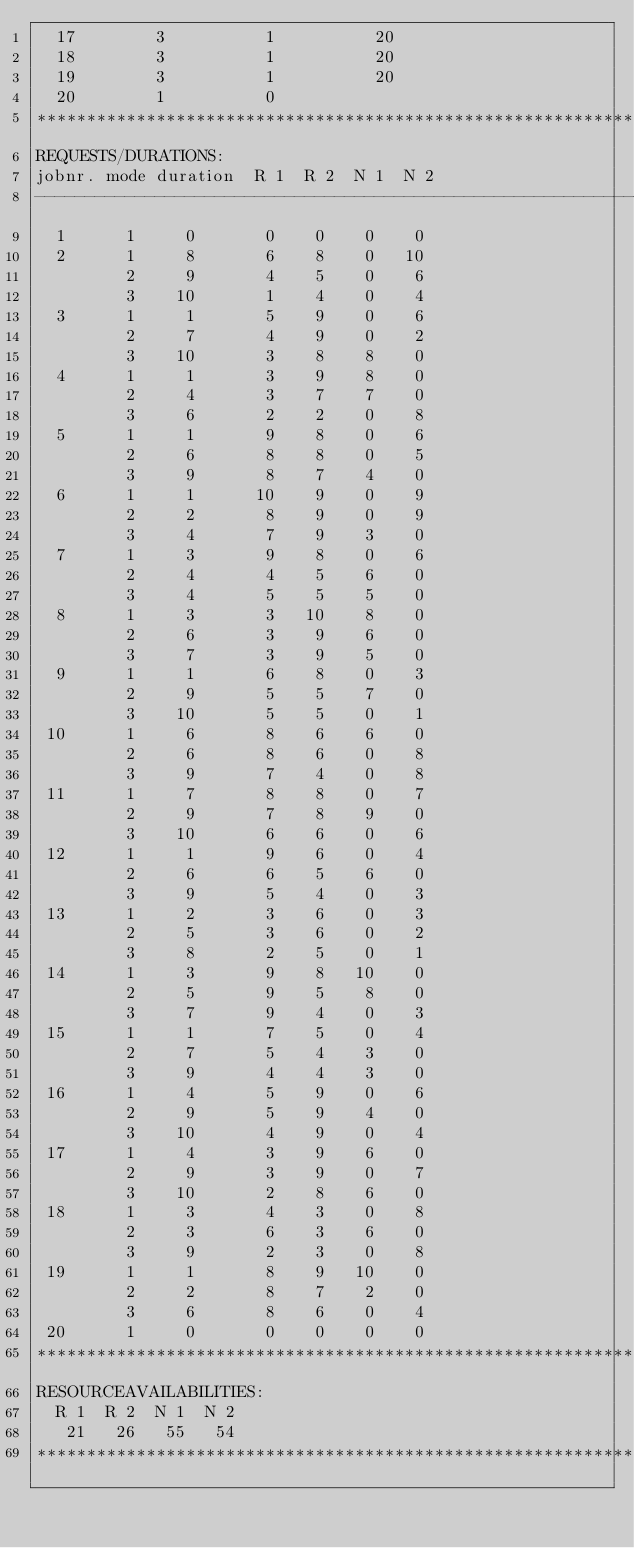<code> <loc_0><loc_0><loc_500><loc_500><_ObjectiveC_>  17        3          1          20
  18        3          1          20
  19        3          1          20
  20        1          0        
************************************************************************
REQUESTS/DURATIONS:
jobnr. mode duration  R 1  R 2  N 1  N 2
------------------------------------------------------------------------
  1      1     0       0    0    0    0
  2      1     8       6    8    0   10
         2     9       4    5    0    6
         3    10       1    4    0    4
  3      1     1       5    9    0    6
         2     7       4    9    0    2
         3    10       3    8    8    0
  4      1     1       3    9    8    0
         2     4       3    7    7    0
         3     6       2    2    0    8
  5      1     1       9    8    0    6
         2     6       8    8    0    5
         3     9       8    7    4    0
  6      1     1      10    9    0    9
         2     2       8    9    0    9
         3     4       7    9    3    0
  7      1     3       9    8    0    6
         2     4       4    5    6    0
         3     4       5    5    5    0
  8      1     3       3   10    8    0
         2     6       3    9    6    0
         3     7       3    9    5    0
  9      1     1       6    8    0    3
         2     9       5    5    7    0
         3    10       5    5    0    1
 10      1     6       8    6    6    0
         2     6       8    6    0    8
         3     9       7    4    0    8
 11      1     7       8    8    0    7
         2     9       7    8    9    0
         3    10       6    6    0    6
 12      1     1       9    6    0    4
         2     6       6    5    6    0
         3     9       5    4    0    3
 13      1     2       3    6    0    3
         2     5       3    6    0    2
         3     8       2    5    0    1
 14      1     3       9    8   10    0
         2     5       9    5    8    0
         3     7       9    4    0    3
 15      1     1       7    5    0    4
         2     7       5    4    3    0
         3     9       4    4    3    0
 16      1     4       5    9    0    6
         2     9       5    9    4    0
         3    10       4    9    0    4
 17      1     4       3    9    6    0
         2     9       3    9    0    7
         3    10       2    8    6    0
 18      1     3       4    3    0    8
         2     3       6    3    6    0
         3     9       2    3    0    8
 19      1     1       8    9   10    0
         2     2       8    7    2    0
         3     6       8    6    0    4
 20      1     0       0    0    0    0
************************************************************************
RESOURCEAVAILABILITIES:
  R 1  R 2  N 1  N 2
   21   26   55   54
************************************************************************
</code> 